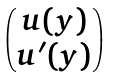<formula> <loc_0><loc_0><loc_500><loc_500>\begin{pmatrix} u ( y ) \\ u ^ { \prime } ( y ) \end{pmatrix}</formula> 